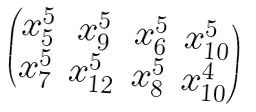Convert formula to latex. <formula><loc_0><loc_0><loc_500><loc_500>\begin{pmatrix} x _ { 5 } ^ { 5 } & x _ { 9 } ^ { 5 } & x _ { 6 } ^ { 5 } & x _ { 1 0 } ^ { 5 } \\ x _ { 7 } ^ { 5 } & x _ { 1 2 } ^ { 5 } & x _ { 8 } ^ { 5 } & x _ { 1 0 } ^ { 4 } \end{pmatrix}</formula> 